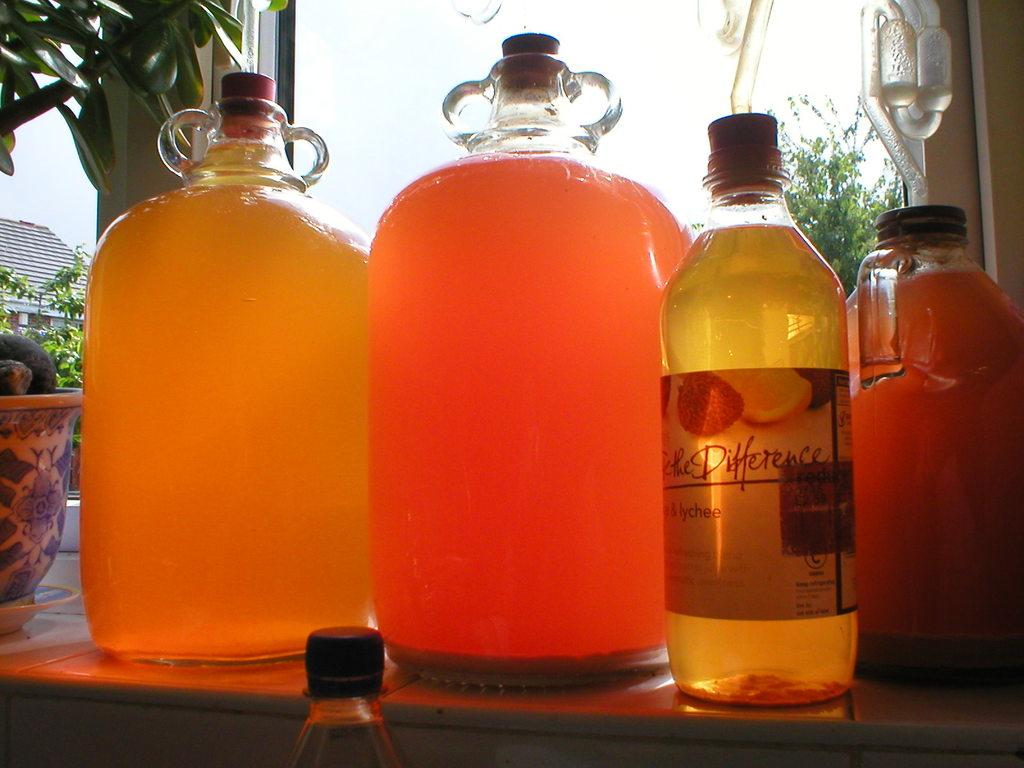<image>
Provide a brief description of the given image. Gallon jugs of lychee brewing on the counter including the Feel the Difference brand. 